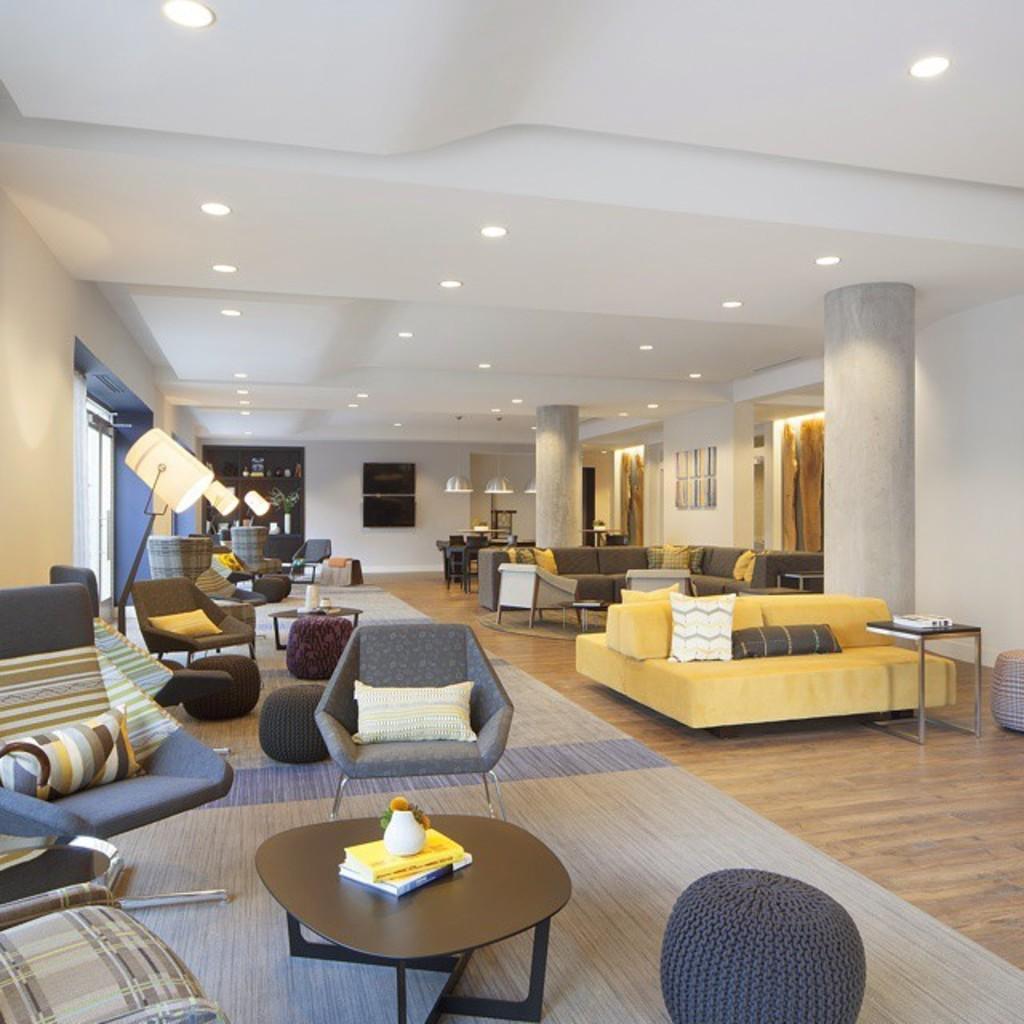Please provide a concise description of this image. In this picture we can see interior of the hall, in that we can find chairs, tables, couple of lights and pillows. 